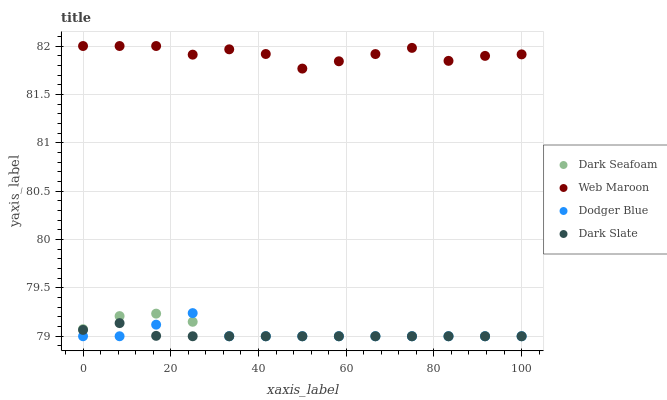Does Dark Slate have the minimum area under the curve?
Answer yes or no. Yes. Does Web Maroon have the maximum area under the curve?
Answer yes or no. Yes. Does Dark Seafoam have the minimum area under the curve?
Answer yes or no. No. Does Dark Seafoam have the maximum area under the curve?
Answer yes or no. No. Is Dark Slate the smoothest?
Answer yes or no. Yes. Is Web Maroon the roughest?
Answer yes or no. Yes. Is Dark Seafoam the smoothest?
Answer yes or no. No. Is Dark Seafoam the roughest?
Answer yes or no. No. Does Dodger Blue have the lowest value?
Answer yes or no. Yes. Does Web Maroon have the lowest value?
Answer yes or no. No. Does Web Maroon have the highest value?
Answer yes or no. Yes. Does Dark Seafoam have the highest value?
Answer yes or no. No. Is Dark Seafoam less than Web Maroon?
Answer yes or no. Yes. Is Web Maroon greater than Dark Slate?
Answer yes or no. Yes. Does Dodger Blue intersect Dark Slate?
Answer yes or no. Yes. Is Dodger Blue less than Dark Slate?
Answer yes or no. No. Is Dodger Blue greater than Dark Slate?
Answer yes or no. No. Does Dark Seafoam intersect Web Maroon?
Answer yes or no. No. 